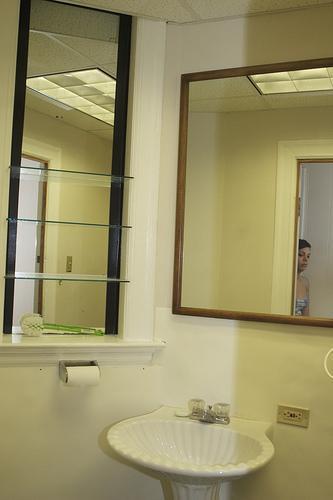How many people are visible in the scene?
Give a very brief answer. 1. How many mirrors are in the photo?
Give a very brief answer. 2. How many outlets are on the wall in front of the sink?
Give a very brief answer. 1. 